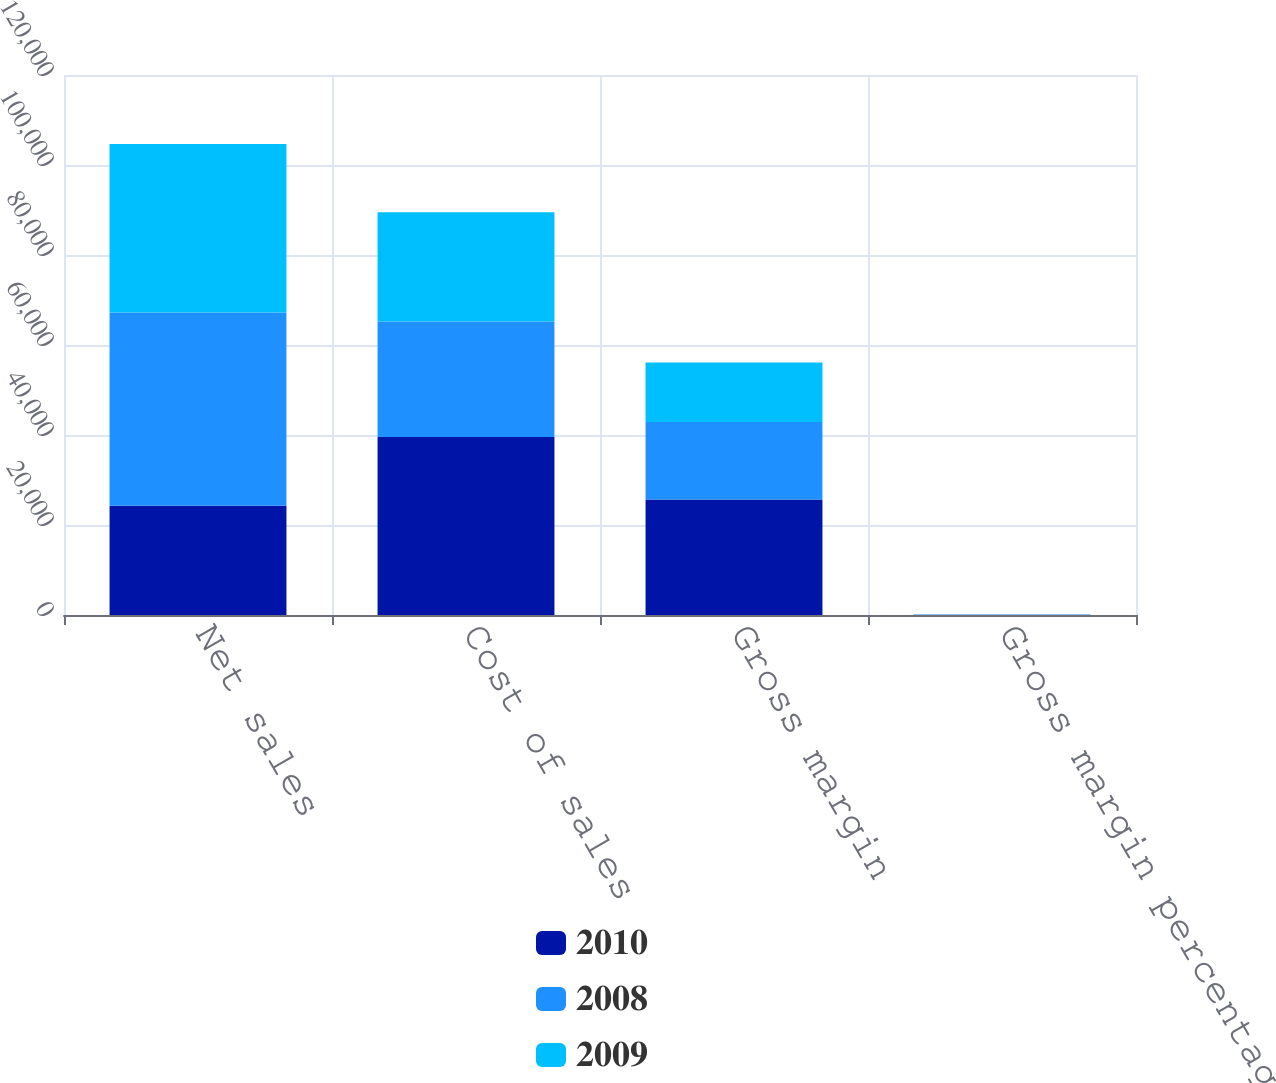<chart> <loc_0><loc_0><loc_500><loc_500><stacked_bar_chart><ecel><fcel>Net sales<fcel>Cost of sales<fcel>Gross margin<fcel>Gross margin percentage<nl><fcel>2010<fcel>24294<fcel>39541<fcel>25684<fcel>39.4<nl><fcel>2008<fcel>42905<fcel>25683<fcel>17222<fcel>40.1<nl><fcel>2009<fcel>37491<fcel>24294<fcel>13197<fcel>35.2<nl></chart> 